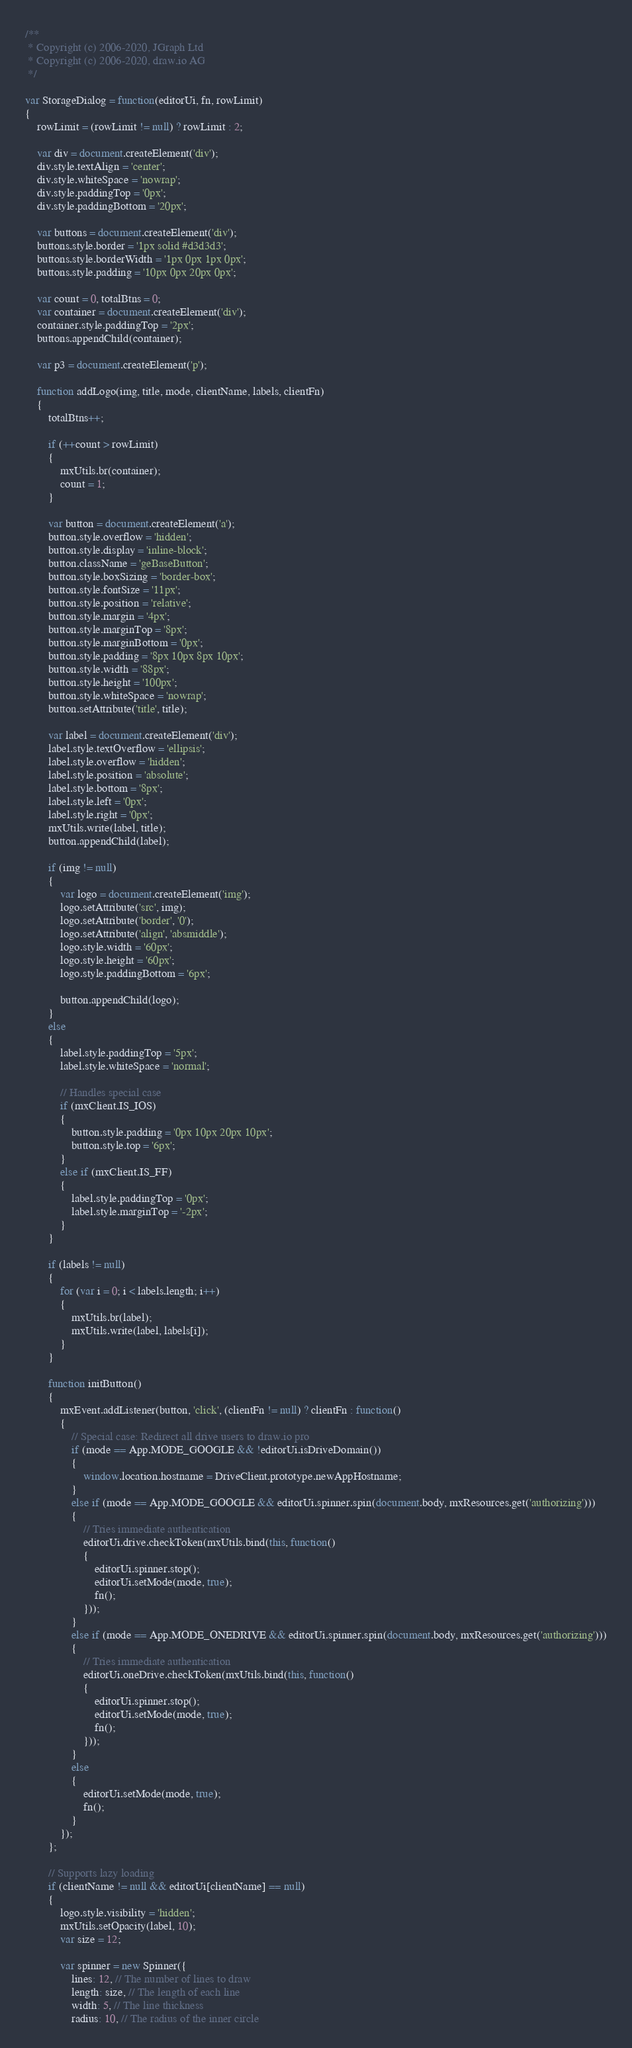Convert code to text. <code><loc_0><loc_0><loc_500><loc_500><_JavaScript_>/**
 * Copyright (c) 2006-2020, JGraph Ltd
 * Copyright (c) 2006-2020, draw.io AG
 */

var StorageDialog = function(editorUi, fn, rowLimit)
{
	rowLimit = (rowLimit != null) ? rowLimit : 2;
	
	var div = document.createElement('div');
	div.style.textAlign = 'center';
	div.style.whiteSpace = 'nowrap';
	div.style.paddingTop = '0px';
	div.style.paddingBottom = '20px';
	
	var buttons = document.createElement('div');
	buttons.style.border = '1px solid #d3d3d3';
	buttons.style.borderWidth = '1px 0px 1px 0px';
	buttons.style.padding = '10px 0px 20px 0px';
	
	var count = 0, totalBtns = 0;
	var container = document.createElement('div');
	container.style.paddingTop = '2px';
	buttons.appendChild(container);
	
	var p3 = document.createElement('p');
	
	function addLogo(img, title, mode, clientName, labels, clientFn)
	{
		totalBtns++;
		
		if (++count > rowLimit)
		{
			mxUtils.br(container);
			count = 1;
		}
		
		var button = document.createElement('a');
		button.style.overflow = 'hidden';
		button.style.display = 'inline-block';
		button.className = 'geBaseButton';
		button.style.boxSizing = 'border-box';
		button.style.fontSize = '11px';
		button.style.position = 'relative';
		button.style.margin = '4px';
		button.style.marginTop = '8px';
		button.style.marginBottom = '0px';
		button.style.padding = '8px 10px 8px 10px';
		button.style.width = '88px';
		button.style.height = '100px';
		button.style.whiteSpace = 'nowrap';
		button.setAttribute('title', title);
		
		var label = document.createElement('div');
		label.style.textOverflow = 'ellipsis';
		label.style.overflow = 'hidden';
		label.style.position = 'absolute';
		label.style.bottom = '8px';
		label.style.left = '0px';
		label.style.right = '0px';
		mxUtils.write(label, title);
		button.appendChild(label);
		
		if (img != null)
		{
			var logo = document.createElement('img');
			logo.setAttribute('src', img);
			logo.setAttribute('border', '0');
			logo.setAttribute('align', 'absmiddle');
			logo.style.width = '60px';
			logo.style.height = '60px';
			logo.style.paddingBottom = '6px';

			button.appendChild(logo);
		}
		else
		{
			label.style.paddingTop = '5px';
			label.style.whiteSpace = 'normal';
			
			// Handles special case
			if (mxClient.IS_IOS)
			{
				button.style.padding = '0px 10px 20px 10px';
				button.style.top = '6px';
			}
			else if (mxClient.IS_FF)
			{
				label.style.paddingTop = '0px';
				label.style.marginTop = '-2px';
			}
		}
		
		if (labels != null)
		{
			for (var i = 0; i < labels.length; i++)
			{
				mxUtils.br(label);
				mxUtils.write(label, labels[i]);
			}
		}
		
		function initButton()
		{
			mxEvent.addListener(button, 'click', (clientFn != null) ? clientFn : function()
			{
				// Special case: Redirect all drive users to draw.io pro
				if (mode == App.MODE_GOOGLE && !editorUi.isDriveDomain())
				{
					window.location.hostname = DriveClient.prototype.newAppHostname;
				}
				else if (mode == App.MODE_GOOGLE && editorUi.spinner.spin(document.body, mxResources.get('authorizing')))
				{
					// Tries immediate authentication
					editorUi.drive.checkToken(mxUtils.bind(this, function()
					{
						editorUi.spinner.stop();
						editorUi.setMode(mode, true);
						fn();
					}));
				}
				else if (mode == App.MODE_ONEDRIVE && editorUi.spinner.spin(document.body, mxResources.get('authorizing')))
				{
					// Tries immediate authentication
					editorUi.oneDrive.checkToken(mxUtils.bind(this, function()
					{
						editorUi.spinner.stop();
						editorUi.setMode(mode, true);
						fn();
					}));
				}
				else
				{
					editorUi.setMode(mode, true);
					fn();
				}
			});
		};
		
		// Supports lazy loading
		if (clientName != null && editorUi[clientName] == null)
		{
			logo.style.visibility = 'hidden';
			mxUtils.setOpacity(label, 10);
			var size = 12;
			
			var spinner = new Spinner({
				lines: 12, // The number of lines to draw
				length: size, // The length of each line
				width: 5, // The line thickness
				radius: 10, // The radius of the inner circle</code> 